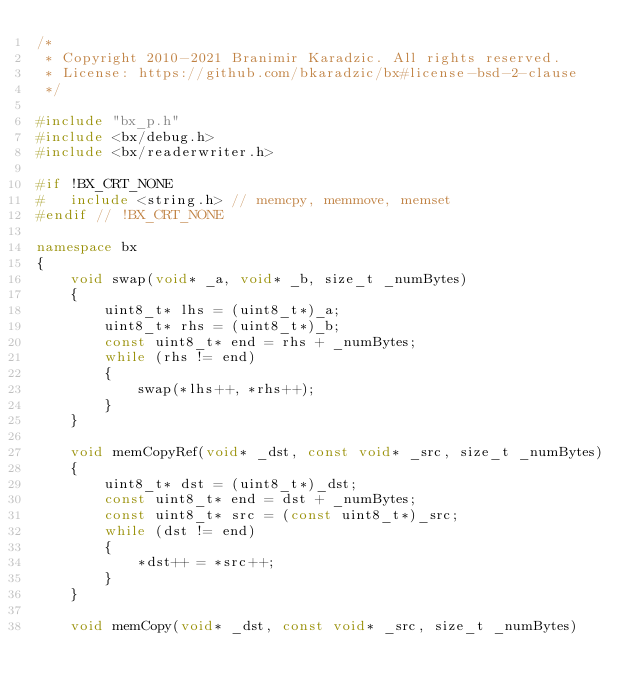<code> <loc_0><loc_0><loc_500><loc_500><_C++_>/*
 * Copyright 2010-2021 Branimir Karadzic. All rights reserved.
 * License: https://github.com/bkaradzic/bx#license-bsd-2-clause
 */

#include "bx_p.h"
#include <bx/debug.h>
#include <bx/readerwriter.h>

#if !BX_CRT_NONE
#	include <string.h> // memcpy, memmove, memset
#endif // !BX_CRT_NONE

namespace bx
{
	void swap(void* _a, void* _b, size_t _numBytes)
	{
		uint8_t* lhs = (uint8_t*)_a;
		uint8_t* rhs = (uint8_t*)_b;
		const uint8_t* end = rhs + _numBytes;
		while (rhs != end)
		{
			swap(*lhs++, *rhs++);
		}
	}

	void memCopyRef(void* _dst, const void* _src, size_t _numBytes)
	{
		uint8_t* dst = (uint8_t*)_dst;
		const uint8_t* end = dst + _numBytes;
		const uint8_t* src = (const uint8_t*)_src;
		while (dst != end)
		{
			*dst++ = *src++;
		}
	}

	void memCopy(void* _dst, const void* _src, size_t _numBytes)</code> 